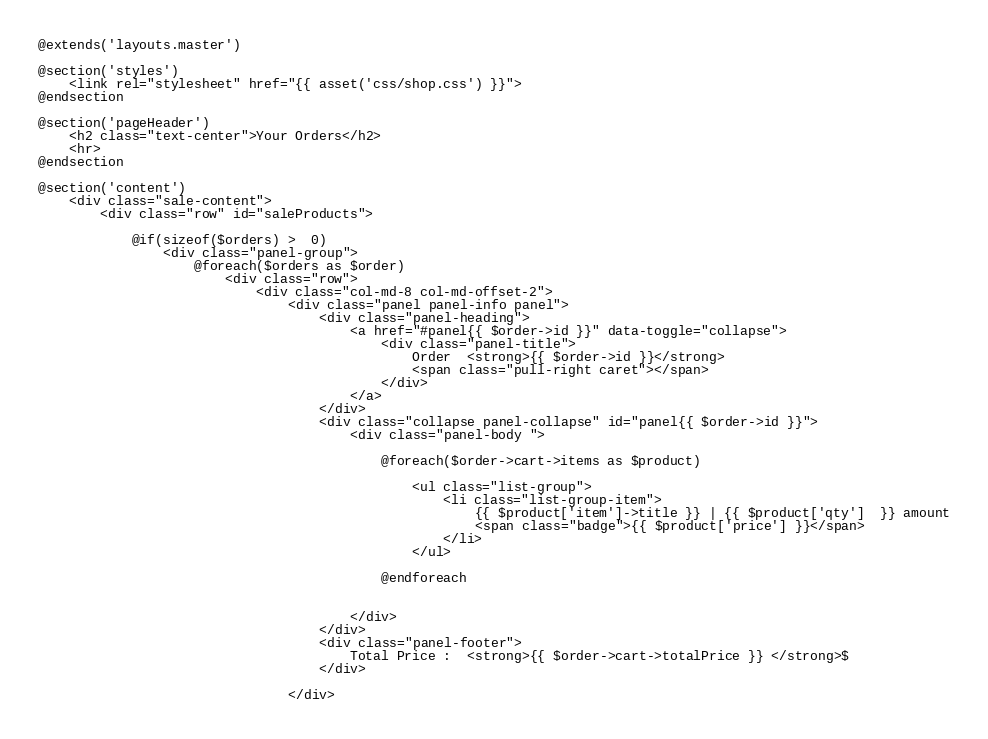<code> <loc_0><loc_0><loc_500><loc_500><_PHP_>@extends('layouts.master')

@section('styles')
    <link rel="stylesheet" href="{{ asset('css/shop.css') }}">
@endsection

@section('pageHeader')
    <h2 class="text-center">Your Orders</h2>
    <hr>
@endsection

@section('content')
    <div class="sale-content">
        <div class="row" id="saleProducts">

            @if(sizeof($orders) >  0)
                <div class="panel-group">
                    @foreach($orders as $order)
                        <div class="row">
                            <div class="col-md-8 col-md-offset-2">
                                <div class="panel panel-info panel">
                                    <div class="panel-heading">
                                        <a href="#panel{{ $order->id }}" data-toggle="collapse">
                                            <div class="panel-title">
                                                Order  <strong>{{ $order->id }}</strong>
                                                <span class="pull-right caret"></span>
                                            </div>
                                        </a>
                                    </div>
                                    <div class="collapse panel-collapse" id="panel{{ $order->id }}">
                                        <div class="panel-body ">

                                            @foreach($order->cart->items as $product)

                                                <ul class="list-group">
                                                    <li class="list-group-item">
                                                        {{ $product['item']->title }} | {{ $product['qty']  }} amount
                                                        <span class="badge">{{ $product['price'] }}</span>
                                                    </li>
                                                </ul>

                                            @endforeach


                                        </div>
                                    </div>
                                    <div class="panel-footer">
                                        Total Price :  <strong>{{ $order->cart->totalPrice }} </strong>$
                                    </div>

                                </div></code> 